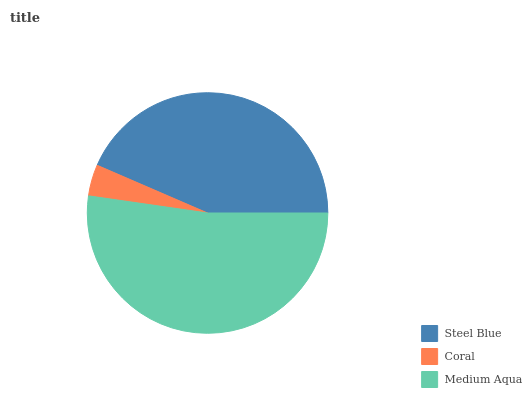Is Coral the minimum?
Answer yes or no. Yes. Is Medium Aqua the maximum?
Answer yes or no. Yes. Is Medium Aqua the minimum?
Answer yes or no. No. Is Coral the maximum?
Answer yes or no. No. Is Medium Aqua greater than Coral?
Answer yes or no. Yes. Is Coral less than Medium Aqua?
Answer yes or no. Yes. Is Coral greater than Medium Aqua?
Answer yes or no. No. Is Medium Aqua less than Coral?
Answer yes or no. No. Is Steel Blue the high median?
Answer yes or no. Yes. Is Steel Blue the low median?
Answer yes or no. Yes. Is Medium Aqua the high median?
Answer yes or no. No. Is Medium Aqua the low median?
Answer yes or no. No. 